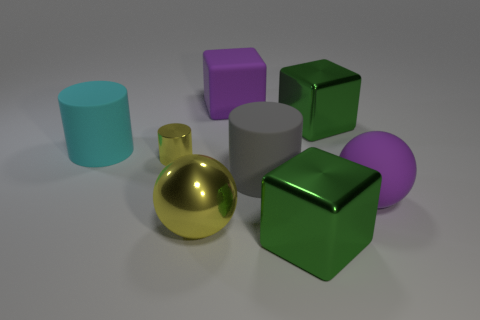Is there anything in the image that suggests size of these objects? There are no familiar reference objects to definitively indicate scale, but the proportions and spacing between objects suggest they are comparable in size to typical household items like a vase or a small box. 